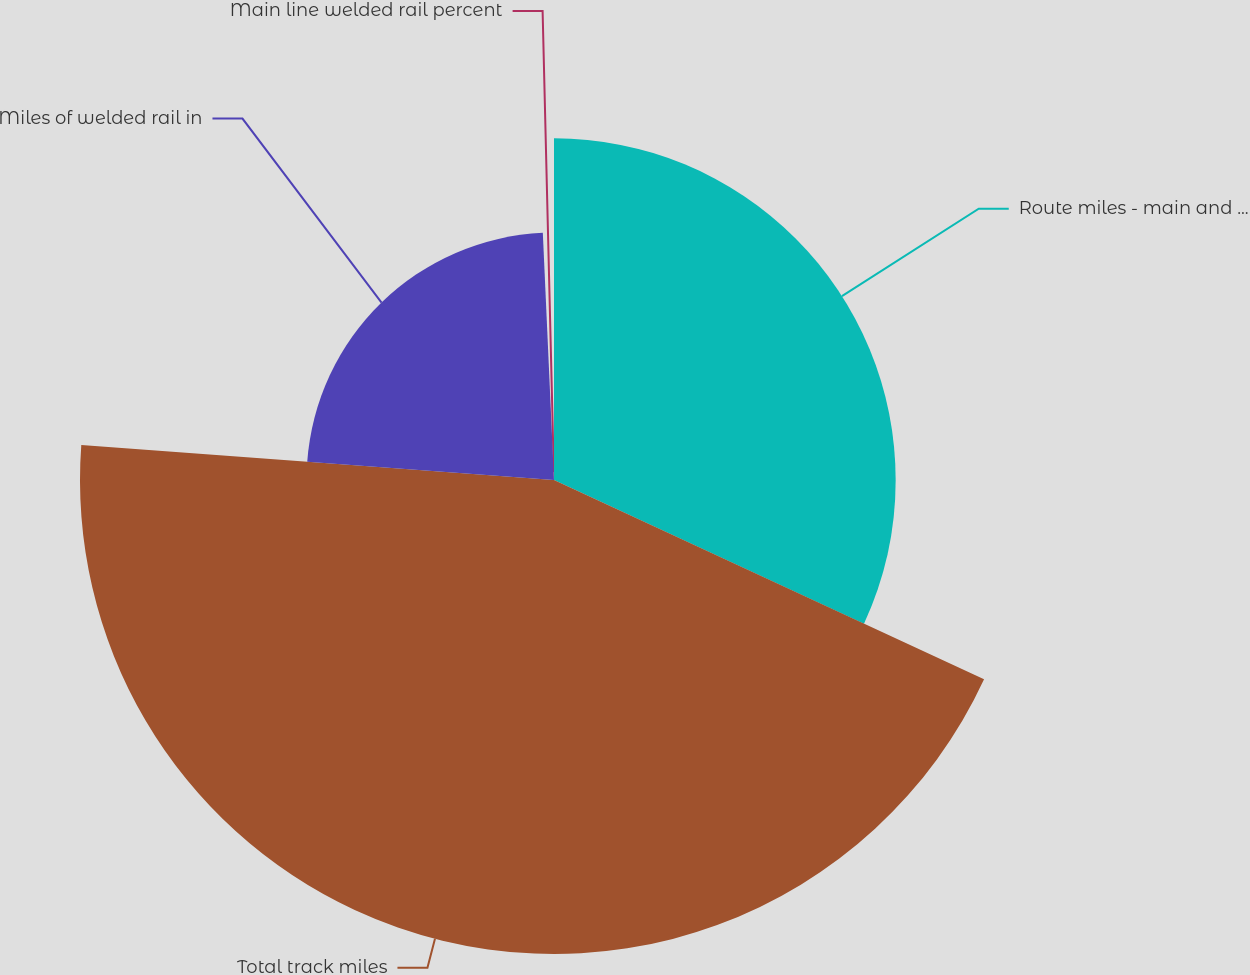Convert chart. <chart><loc_0><loc_0><loc_500><loc_500><pie_chart><fcel>Route miles - main and branch<fcel>Total track miles<fcel>Miles of welded rail in<fcel>Main line welded rail percent<nl><fcel>31.91%<fcel>44.27%<fcel>23.11%<fcel>0.72%<nl></chart> 